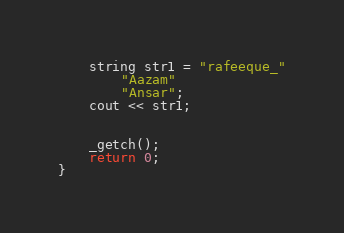<code> <loc_0><loc_0><loc_500><loc_500><_C++_>	string str1 = "rafeeque_"
		"Aazam"
		"Ansar";
	cout << str1;


	_getch();
	return 0;
}
</code> 